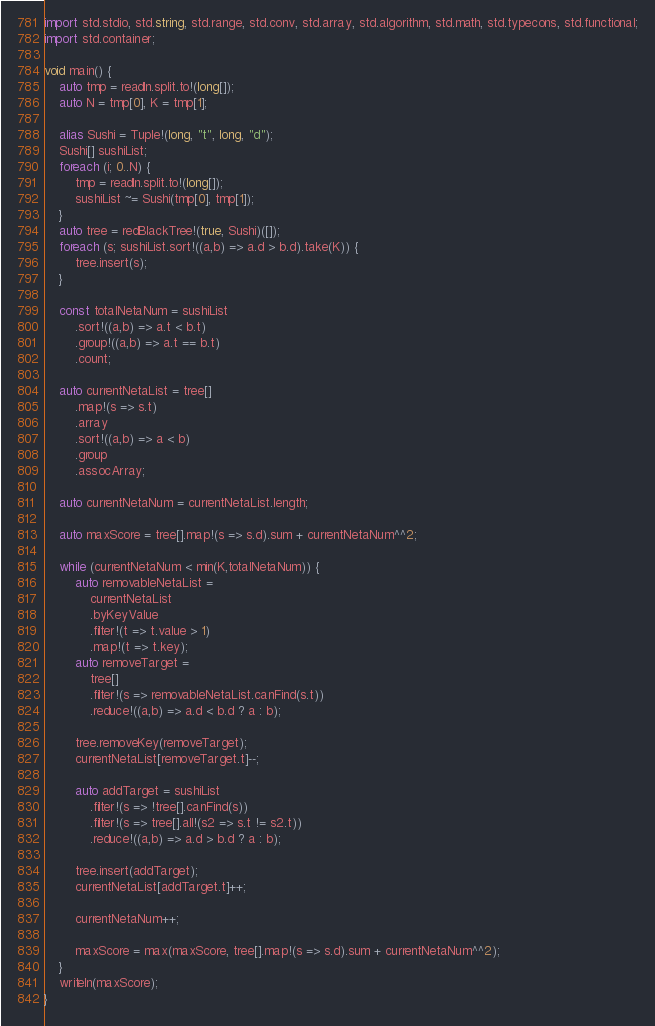Convert code to text. <code><loc_0><loc_0><loc_500><loc_500><_D_>import std.stdio, std.string, std.range, std.conv, std.array, std.algorithm, std.math, std.typecons, std.functional;
import std.container;

void main() {
    auto tmp = readln.split.to!(long[]);
    auto N = tmp[0], K = tmp[1];

    alias Sushi = Tuple!(long, "t", long, "d");
    Sushi[] sushiList;
    foreach (i; 0..N) {
        tmp = readln.split.to!(long[]);
        sushiList ~= Sushi(tmp[0], tmp[1]);
    }
    auto tree = redBlackTree!(true, Sushi)([]);
    foreach (s; sushiList.sort!((a,b) => a.d > b.d).take(K)) {
        tree.insert(s);
    }

    const totalNetaNum = sushiList
        .sort!((a,b) => a.t < b.t)
        .group!((a,b) => a.t == b.t)
        .count;

    auto currentNetaList = tree[]
        .map!(s => s.t)
        .array
        .sort!((a,b) => a < b)
        .group
        .assocArray;

    auto currentNetaNum = currentNetaList.length;

    auto maxScore = tree[].map!(s => s.d).sum + currentNetaNum^^2;

    while (currentNetaNum < min(K,totalNetaNum)) {
        auto removableNetaList = 
            currentNetaList
            .byKeyValue
            .filter!(t => t.value > 1)
            .map!(t => t.key);
        auto removeTarget = 
            tree[]
            .filter!(s => removableNetaList.canFind(s.t))
            .reduce!((a,b) => a.d < b.d ? a : b);
        
        tree.removeKey(removeTarget);
        currentNetaList[removeTarget.t]--;

        auto addTarget = sushiList
            .filter!(s => !tree[].canFind(s))
            .filter!(s => tree[].all!(s2 => s.t != s2.t))
            .reduce!((a,b) => a.d > b.d ? a : b);

        tree.insert(addTarget);
        currentNetaList[addTarget.t]++;

        currentNetaNum++;

        maxScore = max(maxScore, tree[].map!(s => s.d).sum + currentNetaNum^^2);
    }
    writeln(maxScore);
}

</code> 